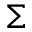Convert formula to latex. <formula><loc_0><loc_0><loc_500><loc_500>\Sigma</formula> 